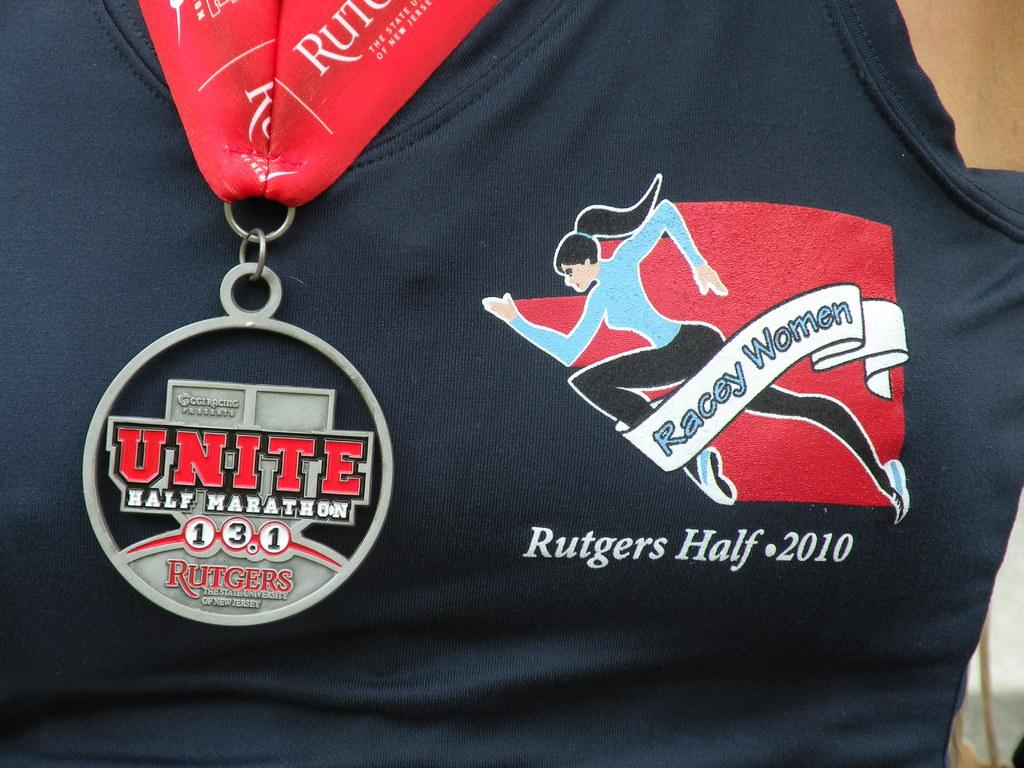Provide a one-sentence caption for the provided image. A women wears a medal for Unite Half Marathon. 